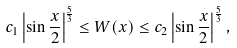Convert formula to latex. <formula><loc_0><loc_0><loc_500><loc_500>c _ { 1 } \left | \sin \frac { x } { 2 } \right | ^ { \frac { 5 } { 3 } } \leq W ( x ) \leq c _ { 2 } \left | \sin \frac { x } { 2 } \right | ^ { \frac { 5 } { 3 } } ,</formula> 